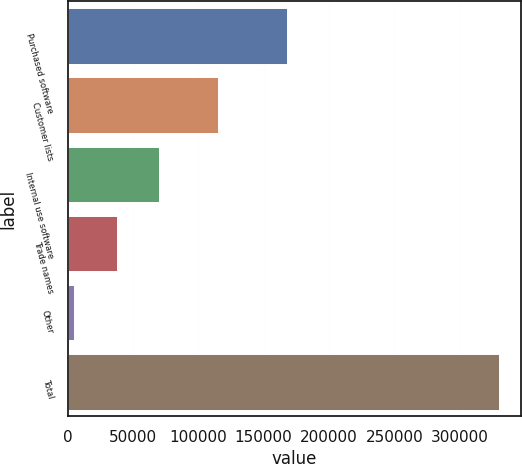Convert chart. <chart><loc_0><loc_0><loc_500><loc_500><bar_chart><fcel>Purchased software<fcel>Customer lists<fcel>Internal use software<fcel>Trade names<fcel>Other<fcel>Total<nl><fcel>168024<fcel>115325<fcel>70100.2<fcel>37590.1<fcel>5080<fcel>330181<nl></chart> 